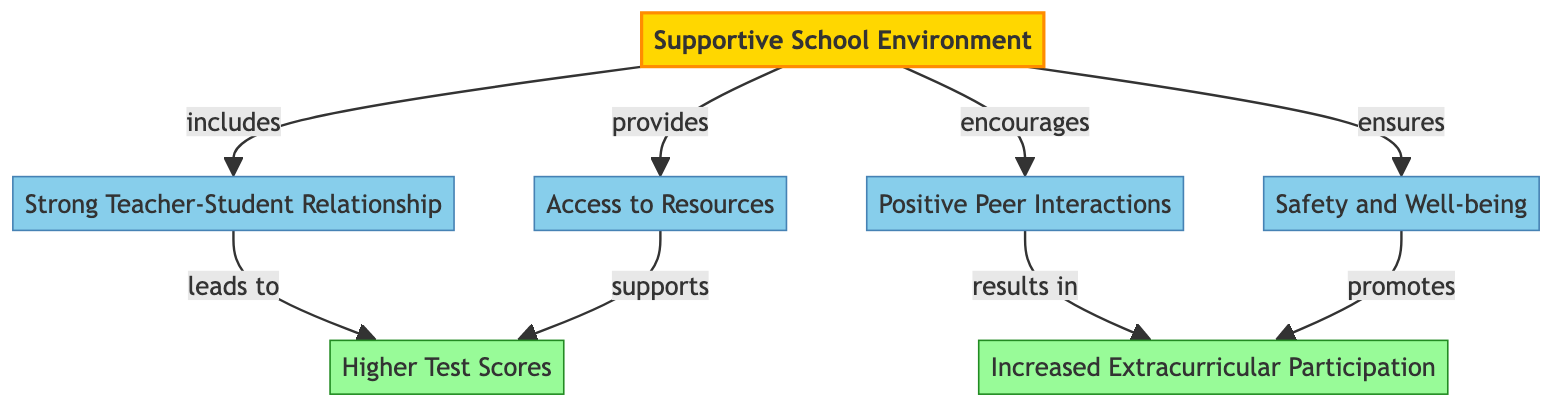What is the main factor in this diagram? The main factor is labeled as "Supportive School Environment" and is at the top of the diagram, indicating its primary role.
Answer: Supportive School Environment How many sub-factors contribute to the supportive school environment? The diagram shows four factors branching from the main factor, which are the elements that contribute to a supportive school environment.
Answer: Four What do strong teacher-student relationships lead to? The diagram indicates that strong teacher-student relationships lead to higher test scores, described by the arrow connection between these two nodes.
Answer: Higher Test Scores Which element ensures student safety and well-being? The safety and well-being element is a sub-factor of the supportive school environment and is specifically labeled, confirming its role in ensuring safety.
Answer: Safety and Well-being What is the result of increased positive peer interactions? The diagram states that increased positive peer interactions result in increased extracurricular participation, establishing a direct link between the two.
Answer: Increased Extracurricular Participation What supports higher test scores according to the diagram? The diagram connects access to resources directly to supporting higher test scores, indicating the relationship clearly.
Answer: Access to Resources How many results are identified in the diagram? There are two results identified in the diagram, which are noted as higher test scores and increased extracurricular participation.
Answer: Two Which sub-factor promotes increased extracurricular participation? The diagram indicates that safety and well-being promotes increased extracurricular participation, highlighting its supportive role.
Answer: Safety and Well-being What is the relationship between access to resources and test scores? Access to resources supports higher test scores, as indicated by the directed line from access to resources to higher test scores.
Answer: Supports 